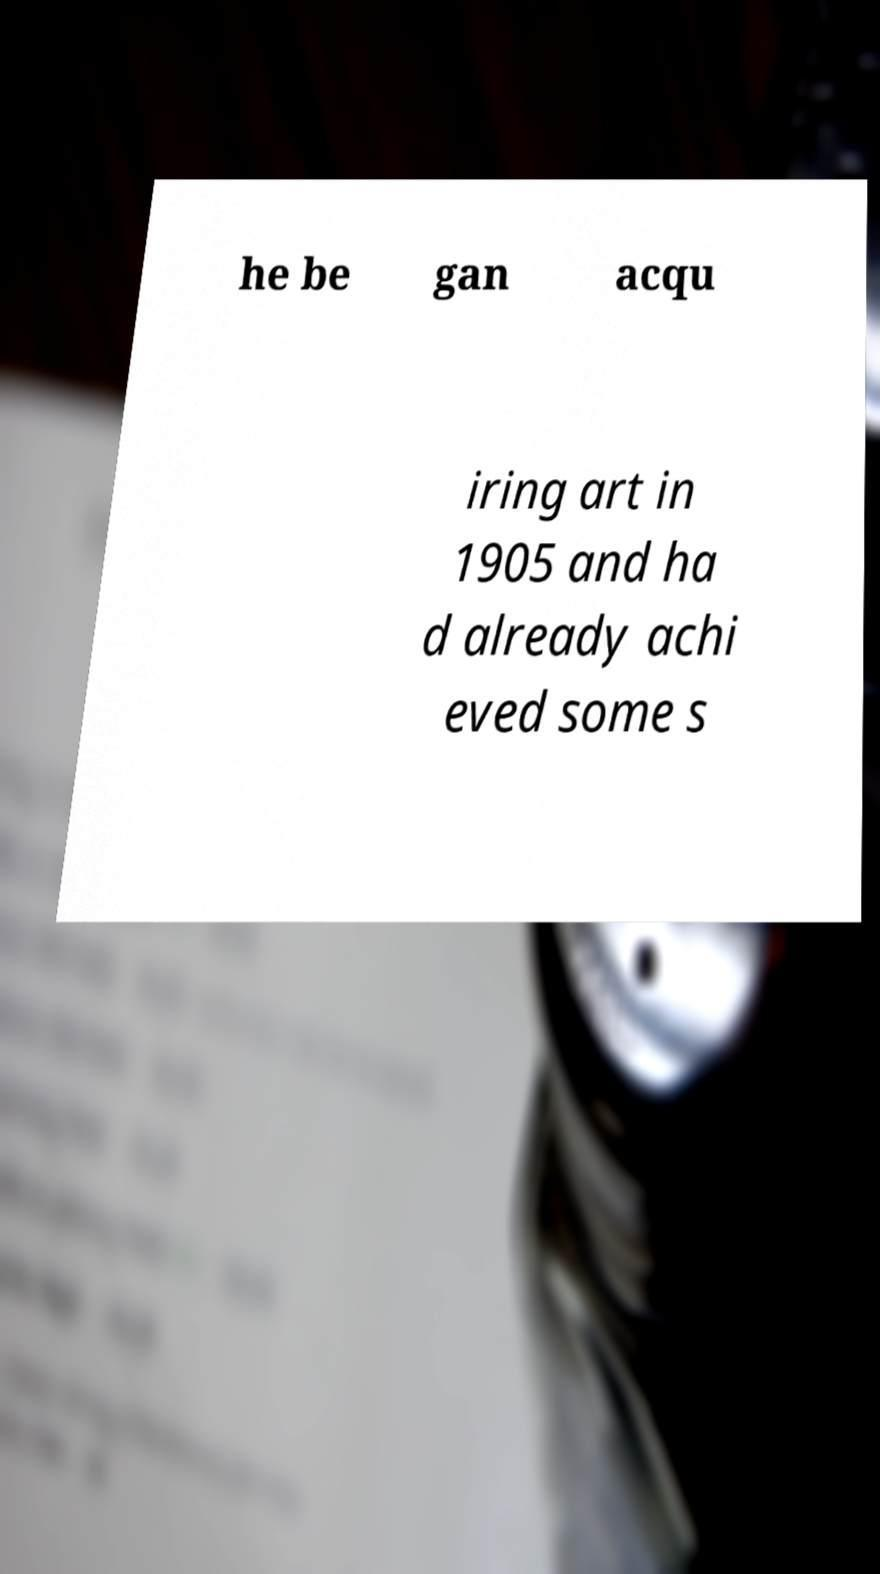Could you extract and type out the text from this image? he be gan acqu iring art in 1905 and ha d already achi eved some s 